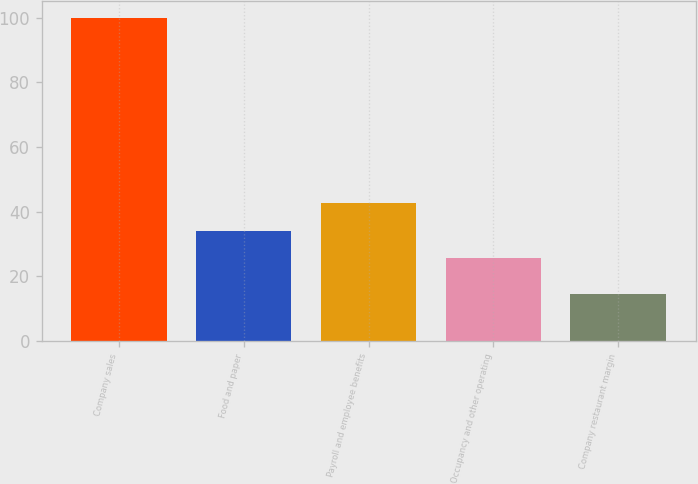Convert chart to OTSL. <chart><loc_0><loc_0><loc_500><loc_500><bar_chart><fcel>Company sales<fcel>Food and paper<fcel>Payroll and employee benefits<fcel>Occupancy and other operating<fcel>Company restaurant margin<nl><fcel>100<fcel>34.14<fcel>42.68<fcel>25.6<fcel>14.6<nl></chart> 